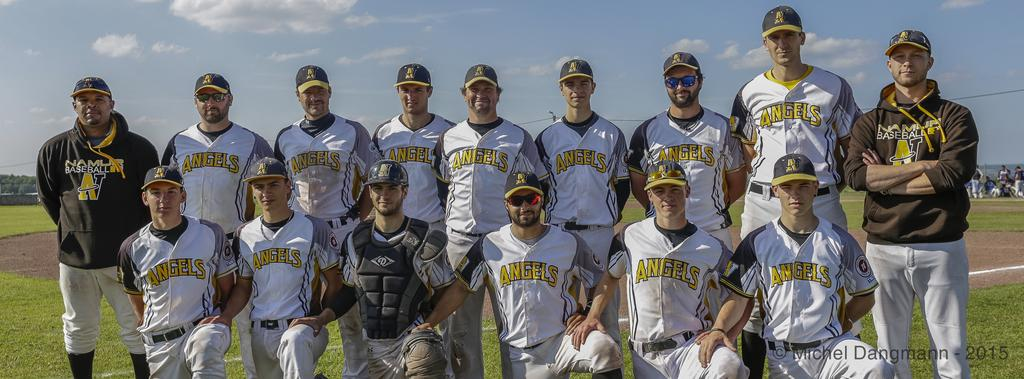Provide a one-sentence caption for the provided image. Baseball team with a jersey saying angels on the front. 